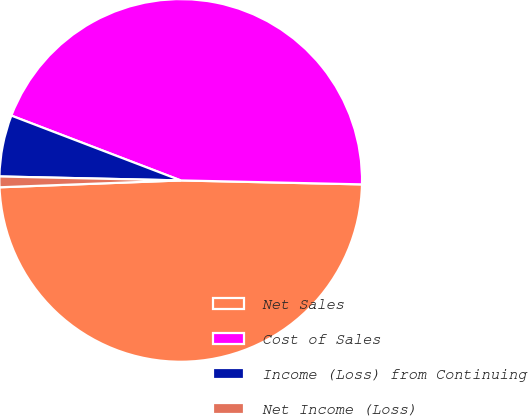Convert chart to OTSL. <chart><loc_0><loc_0><loc_500><loc_500><pie_chart><fcel>Net Sales<fcel>Cost of Sales<fcel>Income (Loss) from Continuing<fcel>Net Income (Loss)<nl><fcel>49.05%<fcel>44.53%<fcel>5.47%<fcel>0.95%<nl></chart> 